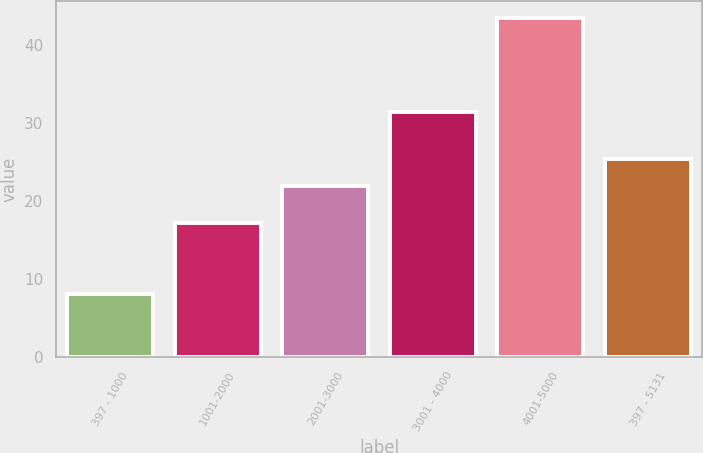<chart> <loc_0><loc_0><loc_500><loc_500><bar_chart><fcel>397 - 1000<fcel>1001-2000<fcel>2001-3000<fcel>3001 - 4000<fcel>4001-5000<fcel>397 - 5131<nl><fcel>8.1<fcel>17.17<fcel>21.9<fcel>31.5<fcel>43.54<fcel>25.44<nl></chart> 